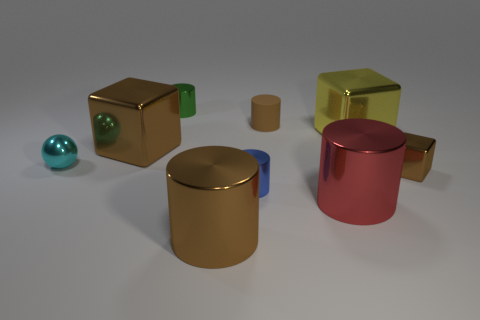Subtract all brown cubes. How many cubes are left? 1 Subtract all green cylinders. Subtract all yellow cubes. How many cylinders are left? 4 Subtract all blue balls. How many purple cylinders are left? 0 Subtract all tiny green objects. Subtract all small green metal things. How many objects are left? 7 Add 4 large brown shiny cylinders. How many large brown shiny cylinders are left? 5 Add 3 yellow shiny objects. How many yellow shiny objects exist? 4 Add 1 small gray metallic cylinders. How many objects exist? 10 Subtract all green cylinders. How many cylinders are left? 4 Subtract 1 brown cubes. How many objects are left? 8 Subtract all cylinders. How many objects are left? 4 